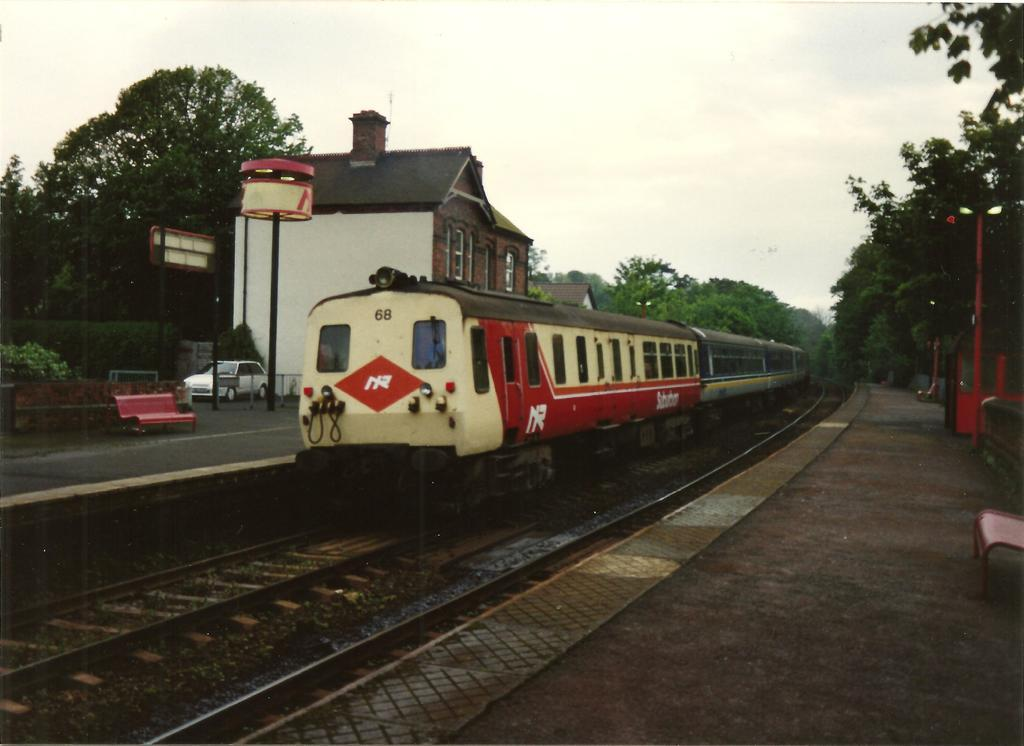What is the main subject of the image? The main subject of the image is a train. Where is the train located in the image? The train is on a railway track. What can be seen in the background of the image? In the background of the image, there is a building, trees, a bench, a car, a railway platform, and the sky. What type of committee is meeting near the train in the image? There is no committee or meeting present in the image; it only features a train on a railway track and various elements in the background. Can you tell me how many bulbs are illuminating the railway platform in the image? There is no mention of bulbs or illumination in the image; it only shows a railway platform as part of the background. 